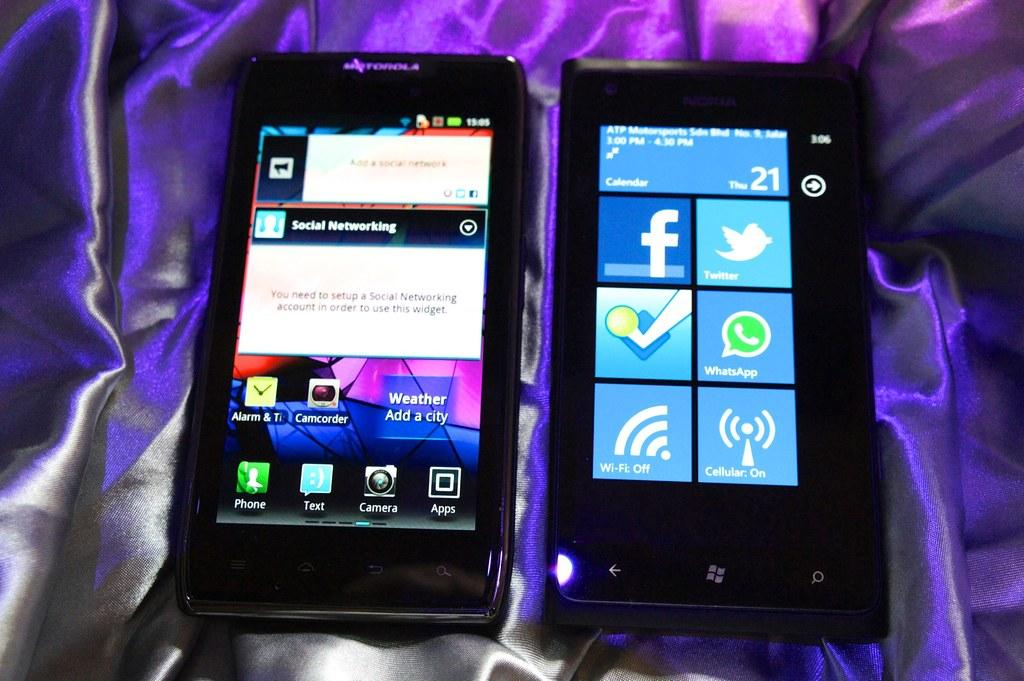Provide a one-sentence caption for the provided image. Two phones on a silk sheet one has Facebook ans Twitter on the screen. 